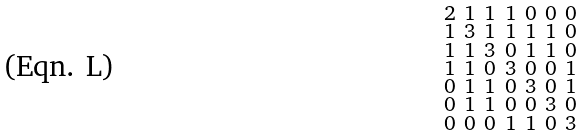<formula> <loc_0><loc_0><loc_500><loc_500>\begin{smallmatrix} 2 & 1 & 1 & 1 & 0 & 0 & 0 \\ 1 & 3 & 1 & 1 & 1 & 1 & 0 \\ 1 & 1 & 3 & 0 & 1 & 1 & 0 \\ 1 & 1 & 0 & 3 & 0 & 0 & 1 \\ 0 & 1 & 1 & 0 & 3 & 0 & 1 \\ 0 & 1 & 1 & 0 & 0 & 3 & 0 \\ 0 & 0 & 0 & 1 & 1 & 0 & 3 \end{smallmatrix}</formula> 